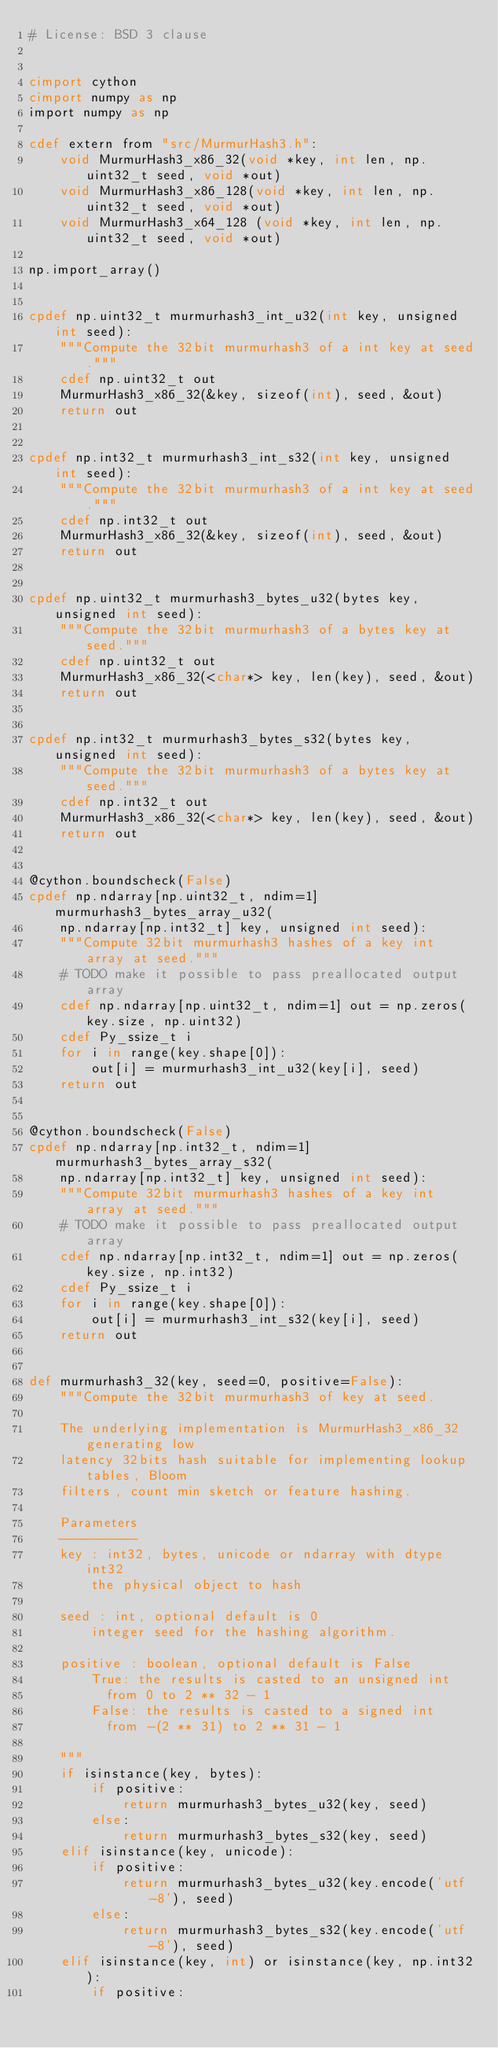Convert code to text. <code><loc_0><loc_0><loc_500><loc_500><_Cython_># License: BSD 3 clause


cimport cython
cimport numpy as np
import numpy as np

cdef extern from "src/MurmurHash3.h":
    void MurmurHash3_x86_32(void *key, int len, np.uint32_t seed, void *out)
    void MurmurHash3_x86_128(void *key, int len, np.uint32_t seed, void *out)
    void MurmurHash3_x64_128 (void *key, int len, np.uint32_t seed, void *out)

np.import_array()


cpdef np.uint32_t murmurhash3_int_u32(int key, unsigned int seed):
    """Compute the 32bit murmurhash3 of a int key at seed."""
    cdef np.uint32_t out
    MurmurHash3_x86_32(&key, sizeof(int), seed, &out)
    return out


cpdef np.int32_t murmurhash3_int_s32(int key, unsigned int seed):
    """Compute the 32bit murmurhash3 of a int key at seed."""
    cdef np.int32_t out
    MurmurHash3_x86_32(&key, sizeof(int), seed, &out)
    return out


cpdef np.uint32_t murmurhash3_bytes_u32(bytes key, unsigned int seed):
    """Compute the 32bit murmurhash3 of a bytes key at seed."""
    cdef np.uint32_t out
    MurmurHash3_x86_32(<char*> key, len(key), seed, &out)
    return out


cpdef np.int32_t murmurhash3_bytes_s32(bytes key, unsigned int seed):
    """Compute the 32bit murmurhash3 of a bytes key at seed."""
    cdef np.int32_t out
    MurmurHash3_x86_32(<char*> key, len(key), seed, &out)
    return out


@cython.boundscheck(False)
cpdef np.ndarray[np.uint32_t, ndim=1] murmurhash3_bytes_array_u32(
    np.ndarray[np.int32_t] key, unsigned int seed):
    """Compute 32bit murmurhash3 hashes of a key int array at seed."""
    # TODO make it possible to pass preallocated output array
    cdef np.ndarray[np.uint32_t, ndim=1] out = np.zeros(key.size, np.uint32)
    cdef Py_ssize_t i
    for i in range(key.shape[0]):
        out[i] = murmurhash3_int_u32(key[i], seed)
    return out


@cython.boundscheck(False)
cpdef np.ndarray[np.int32_t, ndim=1] murmurhash3_bytes_array_s32(
    np.ndarray[np.int32_t] key, unsigned int seed):
    """Compute 32bit murmurhash3 hashes of a key int array at seed."""
    # TODO make it possible to pass preallocated output array
    cdef np.ndarray[np.int32_t, ndim=1] out = np.zeros(key.size, np.int32)
    cdef Py_ssize_t i
    for i in range(key.shape[0]):
        out[i] = murmurhash3_int_s32(key[i], seed)
    return out


def murmurhash3_32(key, seed=0, positive=False):
    """Compute the 32bit murmurhash3 of key at seed.

    The underlying implementation is MurmurHash3_x86_32 generating low
    latency 32bits hash suitable for implementing lookup tables, Bloom
    filters, count min sketch or feature hashing.

    Parameters
    ----------
    key : int32, bytes, unicode or ndarray with dtype int32
        the physical object to hash

    seed : int, optional default is 0
        integer seed for the hashing algorithm.

    positive : boolean, optional default is False
        True: the results is casted to an unsigned int
          from 0 to 2 ** 32 - 1
        False: the results is casted to a signed int
          from -(2 ** 31) to 2 ** 31 - 1

    """
    if isinstance(key, bytes):
        if positive:
            return murmurhash3_bytes_u32(key, seed)
        else:
            return murmurhash3_bytes_s32(key, seed)
    elif isinstance(key, unicode):
        if positive:
            return murmurhash3_bytes_u32(key.encode('utf-8'), seed)
        else:
            return murmurhash3_bytes_s32(key.encode('utf-8'), seed)
    elif isinstance(key, int) or isinstance(key, np.int32):
        if positive:</code> 